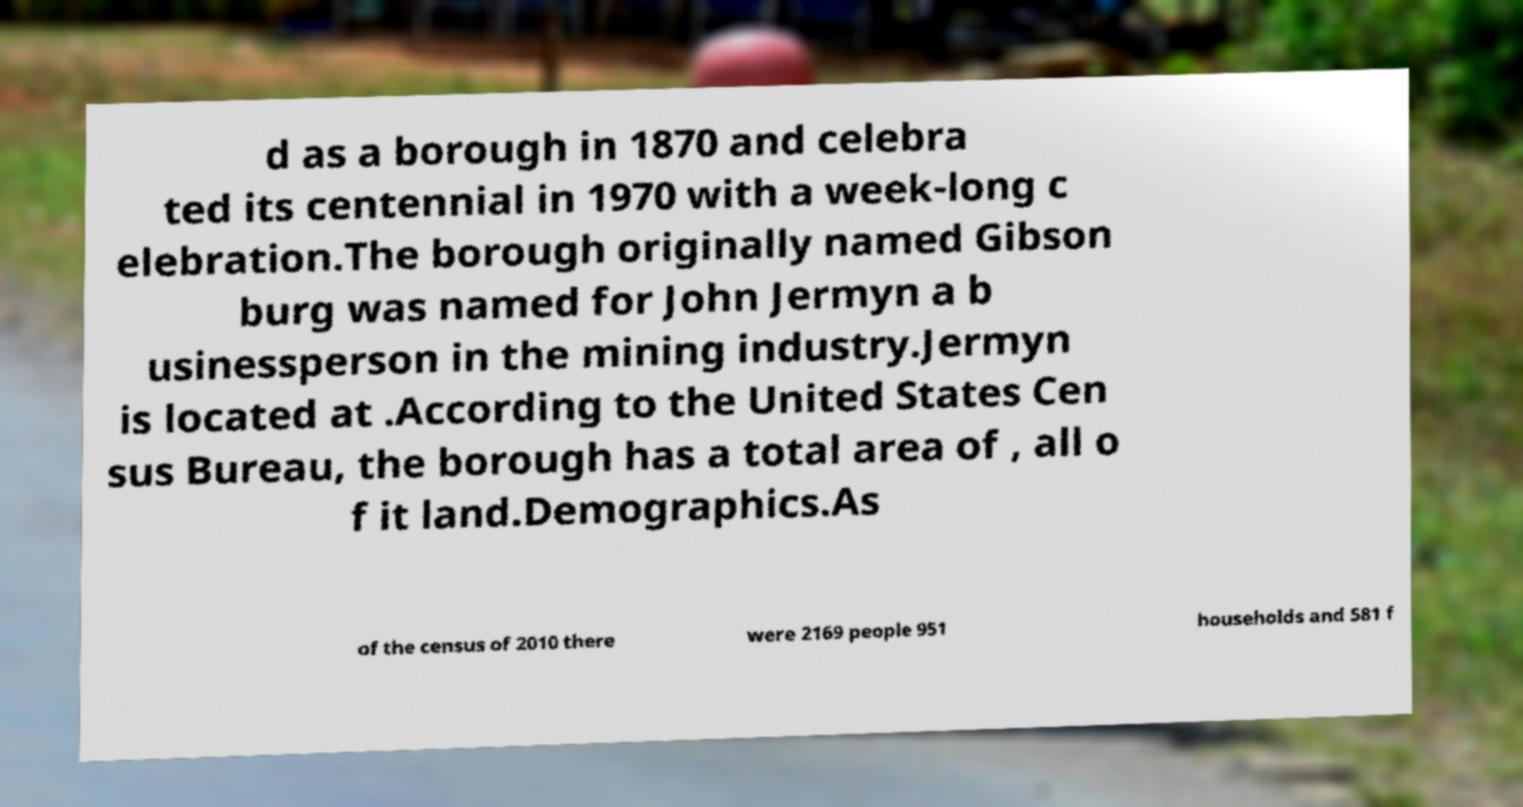Please identify and transcribe the text found in this image. d as a borough in 1870 and celebra ted its centennial in 1970 with a week-long c elebration.The borough originally named Gibson burg was named for John Jermyn a b usinessperson in the mining industry.Jermyn is located at .According to the United States Cen sus Bureau, the borough has a total area of , all o f it land.Demographics.As of the census of 2010 there were 2169 people 951 households and 581 f 